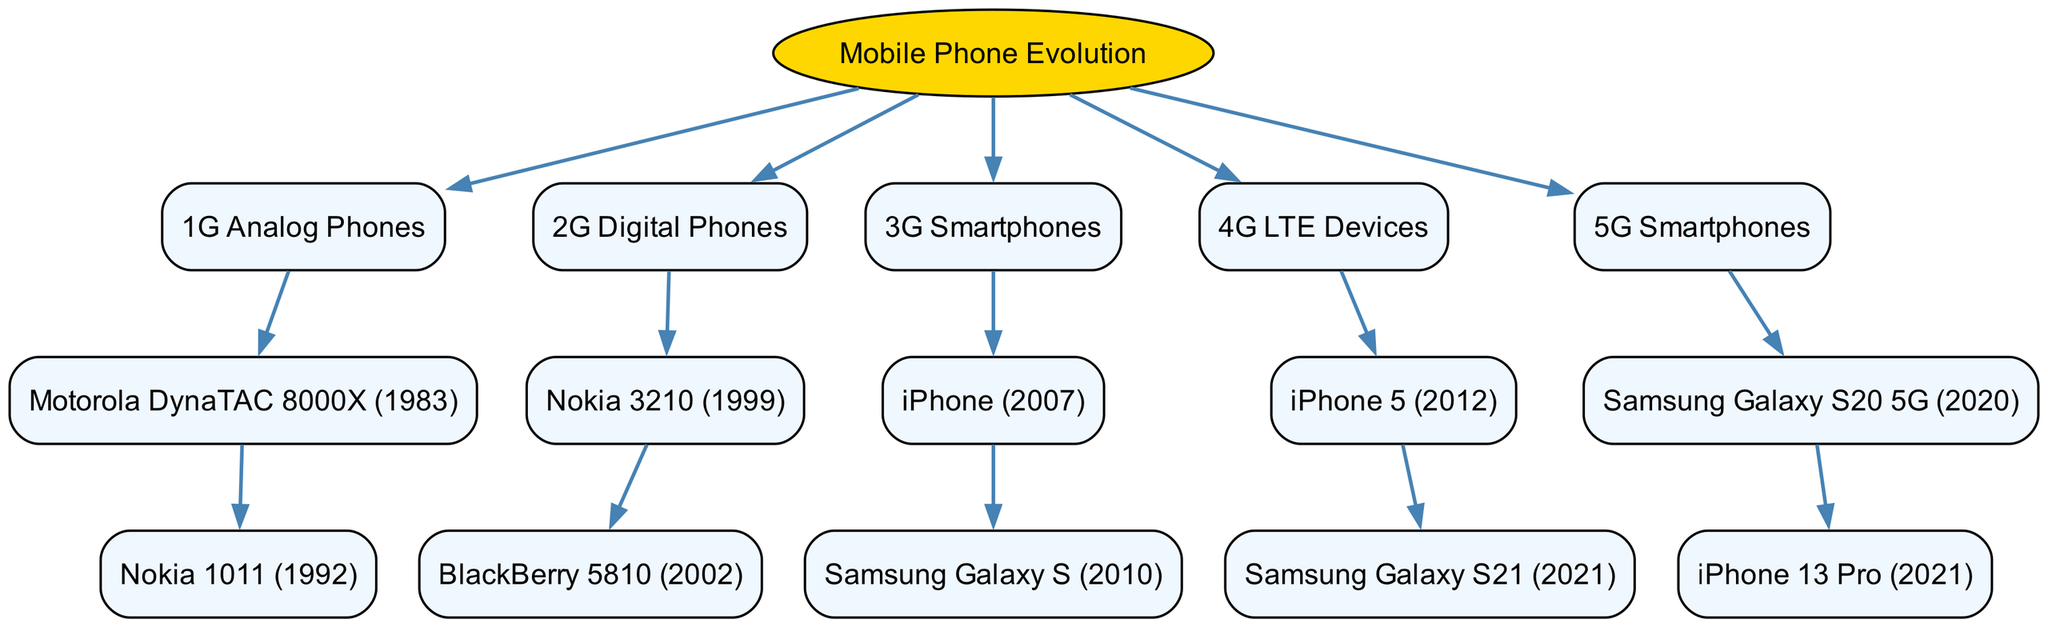What is the root node of the diagram? The root node is explicitly labeled at the top of the diagram, identifying the overall topic as "Mobile Phone Evolution."
Answer: Mobile Phone Evolution How many main generations of mobile phones are depicted in the diagram? The diagram divides the mobile phone evolution into five distinct generations, thus counting the number of main children nodes under the root provides the answer: 5.
Answer: 5 Which phone is the first example of 3G Smartphones? Looking at the 3G section, the first model listed is the "iPhone (2007)," indicating it as the earliest example of this generation.
Answer: iPhone (2007) What is the immediate successor of the Nokia 3210? From the 2G section, under the Nokia 3210, the next phone listed is the "BlackBerry 5810 (2002)," showing its direct lineage.
Answer: BlackBerry 5810 (2002) Which smartphones came out after the Samsung Galaxy S20 5G? The diagram lists the "iPhone 13 Pro (2021)" as the child of the Samsung Galaxy S20 5G, indicating it as the immediate successor.
Answer: iPhone 13 Pro (2021) How are 4G LTE Devices and 5G Smartphones related? By looking at the positioning in the diagram, 4G LTE Devices directly precedes 5G Smartphones, showing a clear chronological relationship where 5G is a subsequent advancement.
Answer: Directly related What type of phones does the node "4G LTE Devices" represent? The node explicitly mentions "4G LTE Devices," which categorically defines the type of phones present in that generation.
Answer: 4G LTE Devices Which mobile phone brand is consistently seen across multiple generations in the diagram? Observing the nodes, both "Samsung" and "iPhone" appear in the 3G, 4G, and 5G categories, indicating their presence in diverse generations.
Answer: Samsung and iPhone What was the first mobile phone in the lineage that supported digital technology? Upon inspection of the second generation, the Nokia 3210 is identified as the initial model that utilized digital technology, leading the 2G evolution.
Answer: Nokia 3210 At what years were the Motorola DynaTAC 8000X and iPhone 5 released? The diagram provides specific years next to each phone: the Motorola DynaTAC 8000X is tagged with 1983 and the iPhone 5 with 2012, marking their respective releases.
Answer: 1983 and 2012 